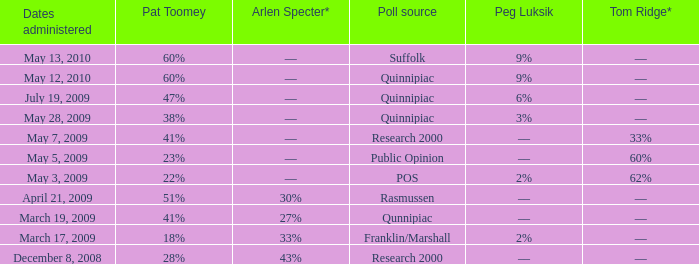Which Poll source has Pat Toomey of 23%? Public Opinion. 